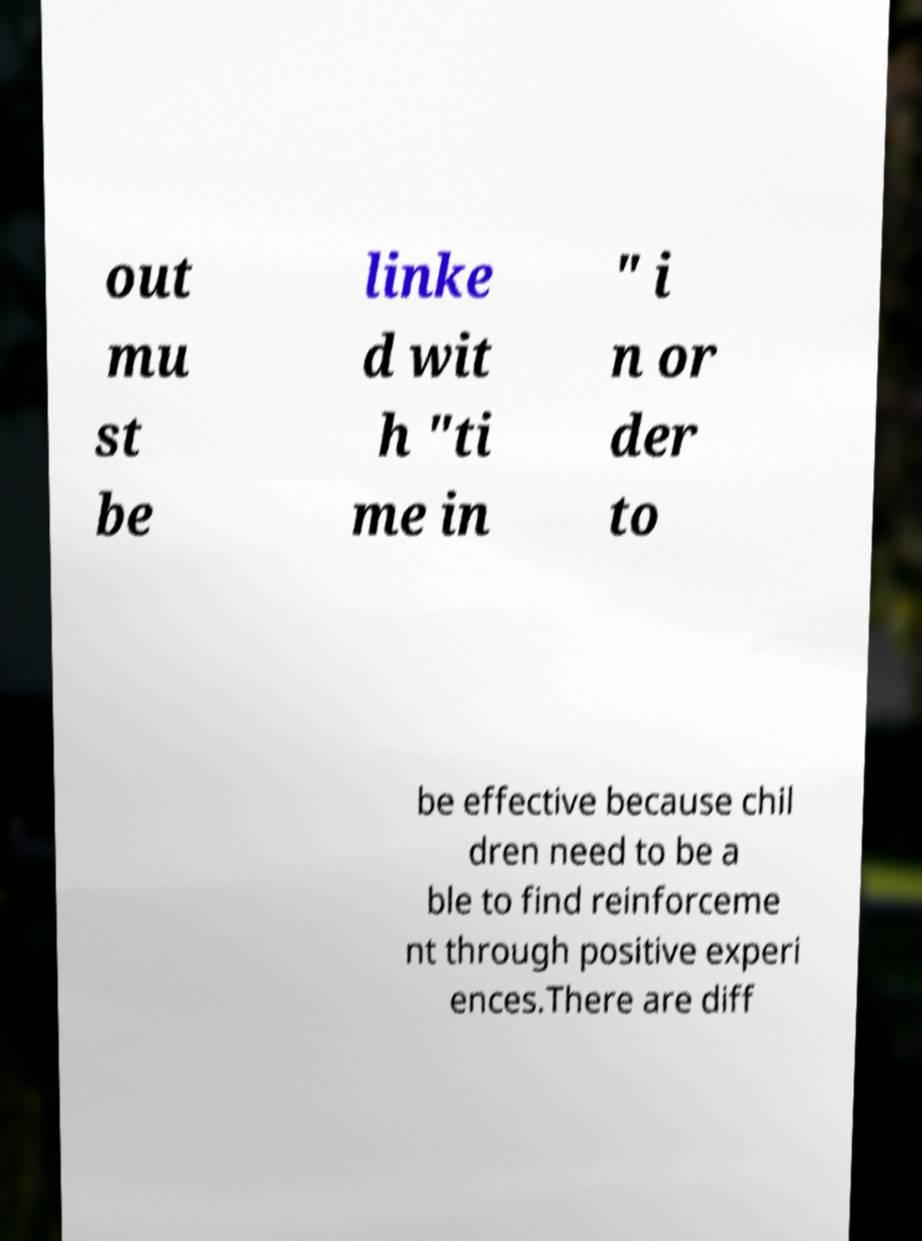I need the written content from this picture converted into text. Can you do that? out mu st be linke d wit h "ti me in " i n or der to be effective because chil dren need to be a ble to find reinforceme nt through positive experi ences.There are diff 